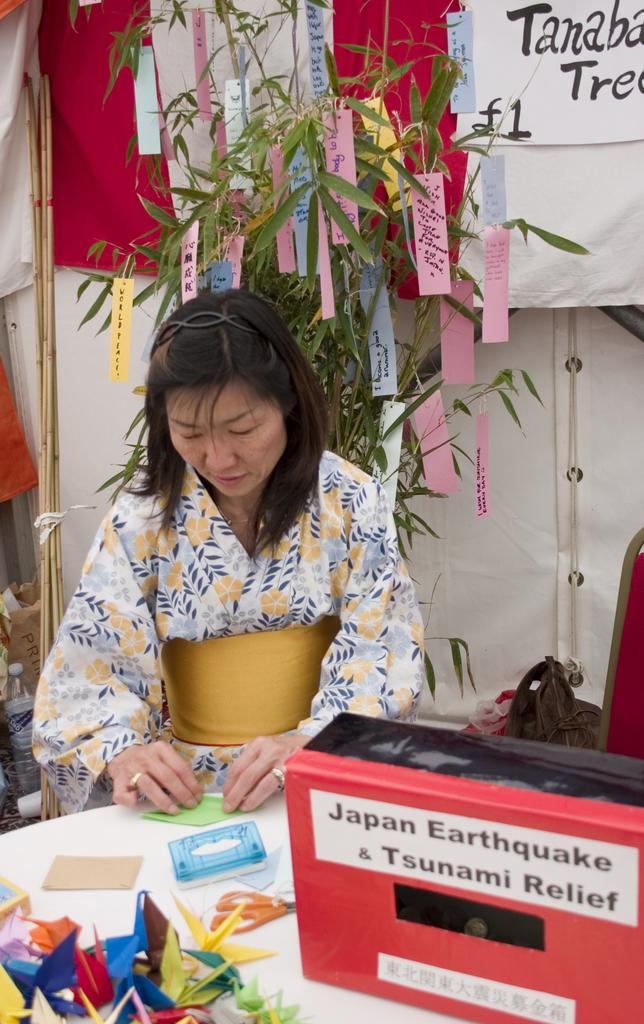What is the woman doing in the image? The woman is sitting at the table in the image. What is on the table with the woman? Papers and a box are present on the table. What can be seen in the background of the image? There is a tree, papers, a curtain associated with a window, sticks, and a wall visible in the background. What type of drink does the woman's dad prefer in the image? There is no mention of a dad or a drink in the image, so it is not possible to answer that question. 